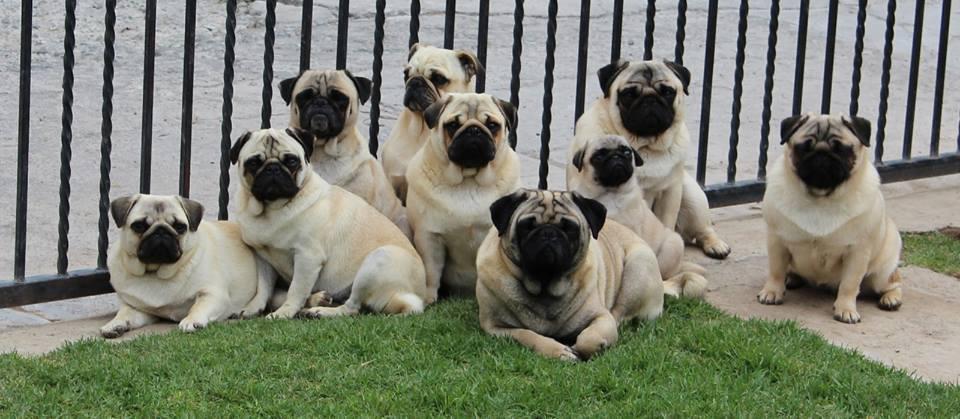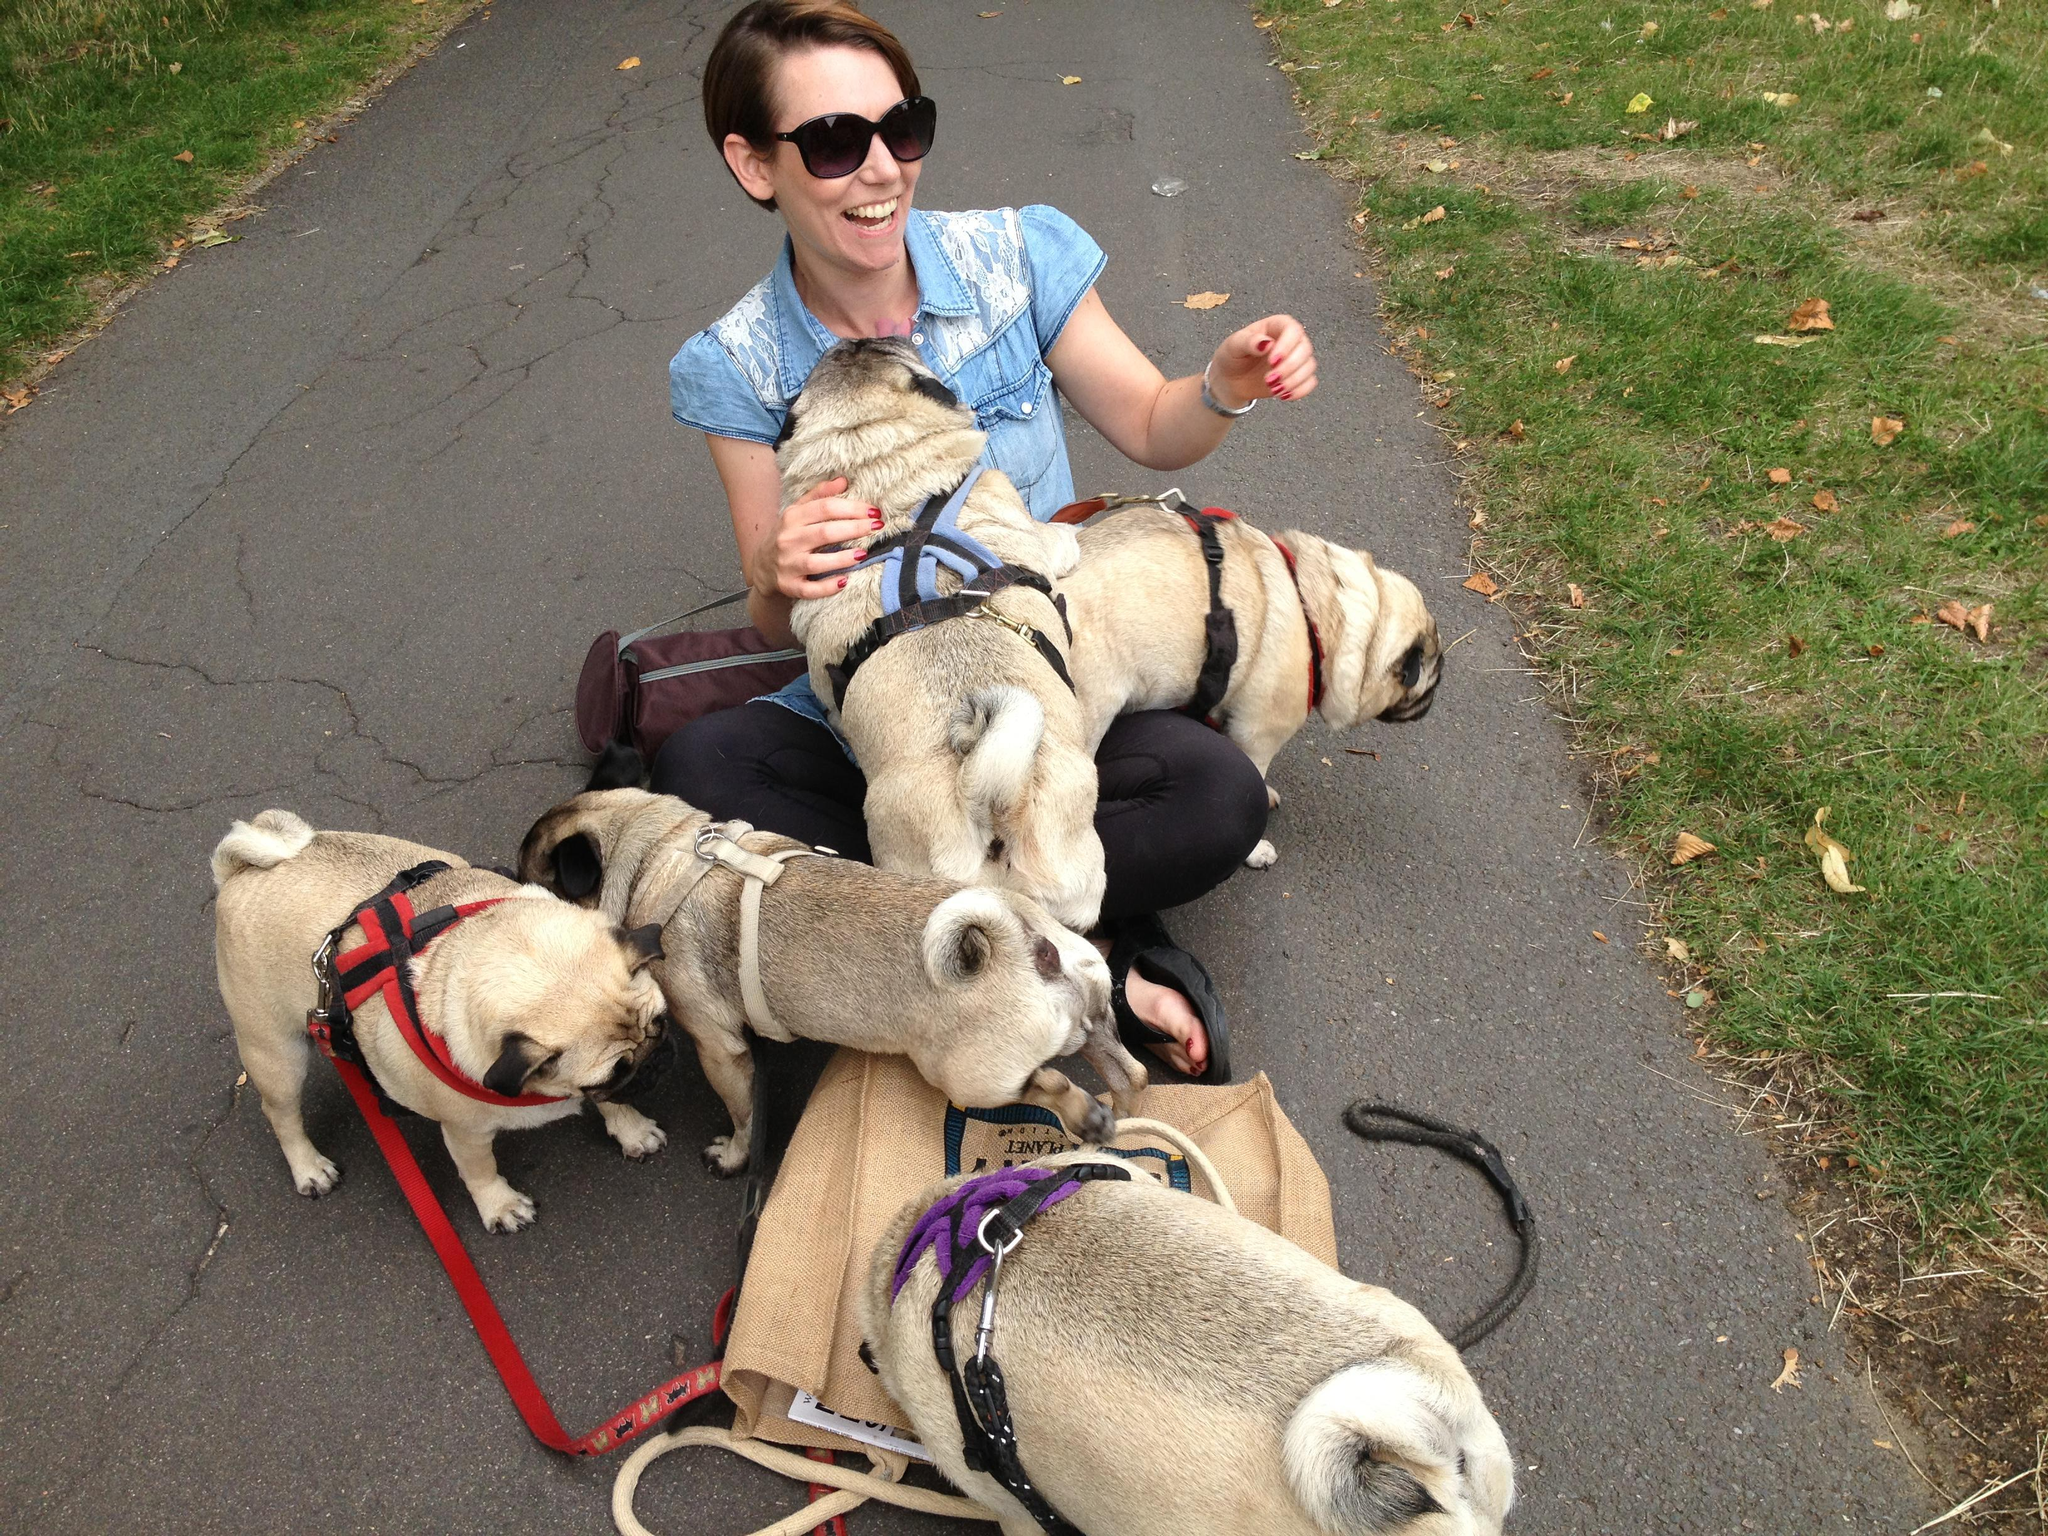The first image is the image on the left, the second image is the image on the right. Considering the images on both sides, is "An image shows multiple pug dogs wearing harnesses." valid? Answer yes or no. Yes. 